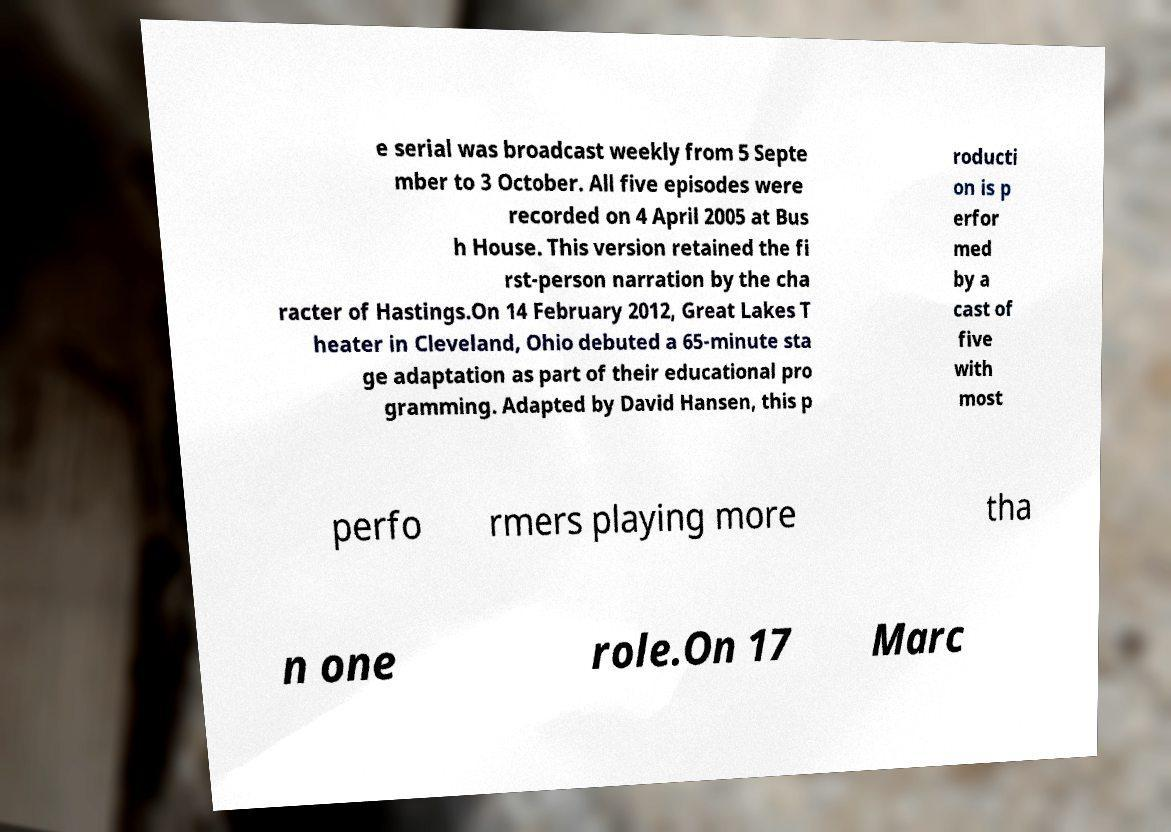Please read and relay the text visible in this image. What does it say? e serial was broadcast weekly from 5 Septe mber to 3 October. All five episodes were recorded on 4 April 2005 at Bus h House. This version retained the fi rst-person narration by the cha racter of Hastings.On 14 February 2012, Great Lakes T heater in Cleveland, Ohio debuted a 65-minute sta ge adaptation as part of their educational pro gramming. Adapted by David Hansen, this p roducti on is p erfor med by a cast of five with most perfo rmers playing more tha n one role.On 17 Marc 